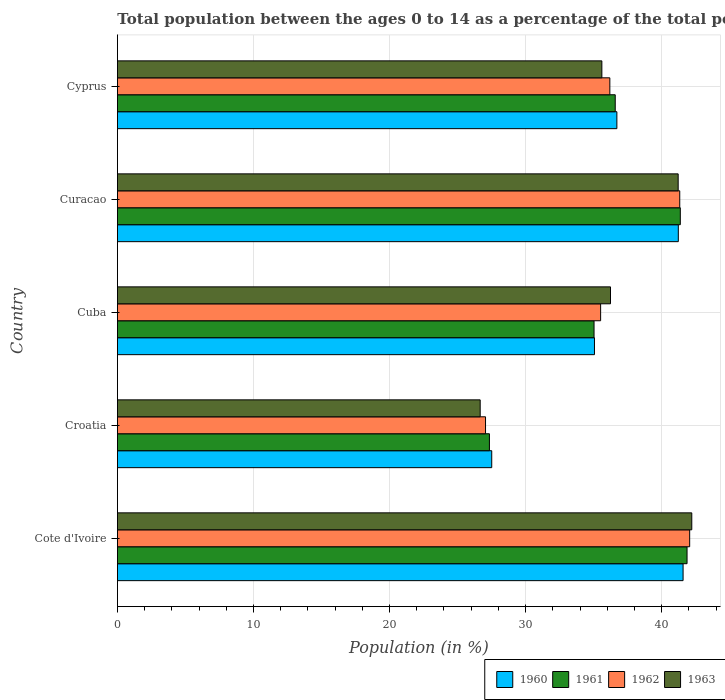What is the label of the 4th group of bars from the top?
Your response must be concise. Croatia. What is the percentage of the population ages 0 to 14 in 1961 in Curacao?
Your answer should be very brief. 41.37. Across all countries, what is the maximum percentage of the population ages 0 to 14 in 1963?
Ensure brevity in your answer.  42.21. Across all countries, what is the minimum percentage of the population ages 0 to 14 in 1962?
Your answer should be compact. 27.05. In which country was the percentage of the population ages 0 to 14 in 1960 maximum?
Offer a very short reply. Cote d'Ivoire. In which country was the percentage of the population ages 0 to 14 in 1963 minimum?
Your answer should be very brief. Croatia. What is the total percentage of the population ages 0 to 14 in 1963 in the graph?
Provide a succinct answer. 181.93. What is the difference between the percentage of the population ages 0 to 14 in 1963 in Curacao and that in Cyprus?
Keep it short and to the point. 5.61. What is the difference between the percentage of the population ages 0 to 14 in 1962 in Croatia and the percentage of the population ages 0 to 14 in 1961 in Cote d'Ivoire?
Your answer should be very brief. -14.81. What is the average percentage of the population ages 0 to 14 in 1961 per country?
Your answer should be very brief. 36.44. What is the difference between the percentage of the population ages 0 to 14 in 1963 and percentage of the population ages 0 to 14 in 1962 in Cyprus?
Give a very brief answer. -0.59. In how many countries, is the percentage of the population ages 0 to 14 in 1963 greater than 18 ?
Make the answer very short. 5. What is the ratio of the percentage of the population ages 0 to 14 in 1962 in Cuba to that in Cyprus?
Give a very brief answer. 0.98. Is the percentage of the population ages 0 to 14 in 1961 in Croatia less than that in Curacao?
Keep it short and to the point. Yes. Is the difference between the percentage of the population ages 0 to 14 in 1963 in Cuba and Curacao greater than the difference between the percentage of the population ages 0 to 14 in 1962 in Cuba and Curacao?
Offer a terse response. Yes. What is the difference between the highest and the second highest percentage of the population ages 0 to 14 in 1963?
Your answer should be compact. 1. What is the difference between the highest and the lowest percentage of the population ages 0 to 14 in 1963?
Keep it short and to the point. 15.55. Is the sum of the percentage of the population ages 0 to 14 in 1963 in Curacao and Cyprus greater than the maximum percentage of the population ages 0 to 14 in 1961 across all countries?
Give a very brief answer. Yes. Is it the case that in every country, the sum of the percentage of the population ages 0 to 14 in 1963 and percentage of the population ages 0 to 14 in 1961 is greater than the sum of percentage of the population ages 0 to 14 in 1962 and percentage of the population ages 0 to 14 in 1960?
Make the answer very short. No. What does the 3rd bar from the top in Curacao represents?
Ensure brevity in your answer.  1961. What does the 2nd bar from the bottom in Croatia represents?
Offer a very short reply. 1961. Is it the case that in every country, the sum of the percentage of the population ages 0 to 14 in 1960 and percentage of the population ages 0 to 14 in 1963 is greater than the percentage of the population ages 0 to 14 in 1961?
Provide a succinct answer. Yes. How many countries are there in the graph?
Give a very brief answer. 5. What is the difference between two consecutive major ticks on the X-axis?
Make the answer very short. 10. Does the graph contain grids?
Your answer should be very brief. Yes. How many legend labels are there?
Give a very brief answer. 4. What is the title of the graph?
Your answer should be compact. Total population between the ages 0 to 14 as a percentage of the total population. Does "2011" appear as one of the legend labels in the graph?
Your answer should be very brief. No. What is the label or title of the X-axis?
Make the answer very short. Population (in %). What is the Population (in %) in 1960 in Cote d'Ivoire?
Your answer should be very brief. 41.57. What is the Population (in %) of 1961 in Cote d'Ivoire?
Give a very brief answer. 41.86. What is the Population (in %) of 1962 in Cote d'Ivoire?
Ensure brevity in your answer.  42.06. What is the Population (in %) in 1963 in Cote d'Ivoire?
Provide a short and direct response. 42.21. What is the Population (in %) of 1960 in Croatia?
Your answer should be very brief. 27.51. What is the Population (in %) of 1961 in Croatia?
Give a very brief answer. 27.34. What is the Population (in %) in 1962 in Croatia?
Your answer should be very brief. 27.05. What is the Population (in %) in 1963 in Croatia?
Keep it short and to the point. 26.66. What is the Population (in %) in 1960 in Cuba?
Keep it short and to the point. 35.06. What is the Population (in %) in 1961 in Cuba?
Your answer should be compact. 35.03. What is the Population (in %) of 1962 in Cuba?
Your response must be concise. 35.51. What is the Population (in %) of 1963 in Cuba?
Offer a very short reply. 36.24. What is the Population (in %) in 1960 in Curacao?
Make the answer very short. 41.22. What is the Population (in %) in 1961 in Curacao?
Your answer should be very brief. 41.37. What is the Population (in %) of 1962 in Curacao?
Ensure brevity in your answer.  41.33. What is the Population (in %) of 1963 in Curacao?
Offer a very short reply. 41.21. What is the Population (in %) in 1960 in Cyprus?
Keep it short and to the point. 36.71. What is the Population (in %) of 1961 in Cyprus?
Ensure brevity in your answer.  36.59. What is the Population (in %) of 1962 in Cyprus?
Provide a succinct answer. 36.19. What is the Population (in %) of 1963 in Cyprus?
Your response must be concise. 35.6. Across all countries, what is the maximum Population (in %) in 1960?
Offer a very short reply. 41.57. Across all countries, what is the maximum Population (in %) in 1961?
Offer a very short reply. 41.86. Across all countries, what is the maximum Population (in %) in 1962?
Your response must be concise. 42.06. Across all countries, what is the maximum Population (in %) in 1963?
Your answer should be very brief. 42.21. Across all countries, what is the minimum Population (in %) of 1960?
Provide a short and direct response. 27.51. Across all countries, what is the minimum Population (in %) of 1961?
Ensure brevity in your answer.  27.34. Across all countries, what is the minimum Population (in %) of 1962?
Offer a terse response. 27.05. Across all countries, what is the minimum Population (in %) in 1963?
Provide a short and direct response. 26.66. What is the total Population (in %) in 1960 in the graph?
Provide a succinct answer. 182.07. What is the total Population (in %) in 1961 in the graph?
Provide a short and direct response. 182.19. What is the total Population (in %) of 1962 in the graph?
Keep it short and to the point. 182.14. What is the total Population (in %) of 1963 in the graph?
Offer a terse response. 181.93. What is the difference between the Population (in %) in 1960 in Cote d'Ivoire and that in Croatia?
Your answer should be compact. 14.06. What is the difference between the Population (in %) in 1961 in Cote d'Ivoire and that in Croatia?
Ensure brevity in your answer.  14.52. What is the difference between the Population (in %) of 1962 in Cote d'Ivoire and that in Croatia?
Your response must be concise. 15. What is the difference between the Population (in %) in 1963 in Cote d'Ivoire and that in Croatia?
Offer a terse response. 15.55. What is the difference between the Population (in %) in 1960 in Cote d'Ivoire and that in Cuba?
Keep it short and to the point. 6.51. What is the difference between the Population (in %) of 1961 in Cote d'Ivoire and that in Cuba?
Give a very brief answer. 6.84. What is the difference between the Population (in %) of 1962 in Cote d'Ivoire and that in Cuba?
Provide a short and direct response. 6.54. What is the difference between the Population (in %) in 1963 in Cote d'Ivoire and that in Cuba?
Your response must be concise. 5.97. What is the difference between the Population (in %) in 1960 in Cote d'Ivoire and that in Curacao?
Keep it short and to the point. 0.35. What is the difference between the Population (in %) of 1961 in Cote d'Ivoire and that in Curacao?
Your answer should be compact. 0.49. What is the difference between the Population (in %) of 1962 in Cote d'Ivoire and that in Curacao?
Your response must be concise. 0.73. What is the difference between the Population (in %) in 1963 in Cote d'Ivoire and that in Curacao?
Ensure brevity in your answer.  1. What is the difference between the Population (in %) of 1960 in Cote d'Ivoire and that in Cyprus?
Keep it short and to the point. 4.87. What is the difference between the Population (in %) of 1961 in Cote d'Ivoire and that in Cyprus?
Your answer should be compact. 5.28. What is the difference between the Population (in %) in 1962 in Cote d'Ivoire and that in Cyprus?
Give a very brief answer. 5.87. What is the difference between the Population (in %) in 1963 in Cote d'Ivoire and that in Cyprus?
Give a very brief answer. 6.61. What is the difference between the Population (in %) of 1960 in Croatia and that in Cuba?
Your response must be concise. -7.55. What is the difference between the Population (in %) in 1961 in Croatia and that in Cuba?
Your answer should be very brief. -7.69. What is the difference between the Population (in %) of 1962 in Croatia and that in Cuba?
Ensure brevity in your answer.  -8.46. What is the difference between the Population (in %) in 1963 in Croatia and that in Cuba?
Provide a succinct answer. -9.58. What is the difference between the Population (in %) in 1960 in Croatia and that in Curacao?
Give a very brief answer. -13.71. What is the difference between the Population (in %) of 1961 in Croatia and that in Curacao?
Give a very brief answer. -14.03. What is the difference between the Population (in %) of 1962 in Croatia and that in Curacao?
Offer a very short reply. -14.27. What is the difference between the Population (in %) in 1963 in Croatia and that in Curacao?
Keep it short and to the point. -14.55. What is the difference between the Population (in %) of 1960 in Croatia and that in Cyprus?
Make the answer very short. -9.2. What is the difference between the Population (in %) of 1961 in Croatia and that in Cyprus?
Make the answer very short. -9.25. What is the difference between the Population (in %) of 1962 in Croatia and that in Cyprus?
Your answer should be very brief. -9.14. What is the difference between the Population (in %) of 1963 in Croatia and that in Cyprus?
Keep it short and to the point. -8.94. What is the difference between the Population (in %) of 1960 in Cuba and that in Curacao?
Your response must be concise. -6.16. What is the difference between the Population (in %) of 1961 in Cuba and that in Curacao?
Keep it short and to the point. -6.34. What is the difference between the Population (in %) in 1962 in Cuba and that in Curacao?
Offer a very short reply. -5.82. What is the difference between the Population (in %) in 1963 in Cuba and that in Curacao?
Your answer should be compact. -4.97. What is the difference between the Population (in %) in 1960 in Cuba and that in Cyprus?
Give a very brief answer. -1.65. What is the difference between the Population (in %) in 1961 in Cuba and that in Cyprus?
Provide a succinct answer. -1.56. What is the difference between the Population (in %) in 1962 in Cuba and that in Cyprus?
Ensure brevity in your answer.  -0.68. What is the difference between the Population (in %) in 1963 in Cuba and that in Cyprus?
Give a very brief answer. 0.63. What is the difference between the Population (in %) of 1960 in Curacao and that in Cyprus?
Your answer should be compact. 4.52. What is the difference between the Population (in %) of 1961 in Curacao and that in Cyprus?
Give a very brief answer. 4.78. What is the difference between the Population (in %) of 1962 in Curacao and that in Cyprus?
Give a very brief answer. 5.14. What is the difference between the Population (in %) of 1963 in Curacao and that in Cyprus?
Offer a very short reply. 5.61. What is the difference between the Population (in %) in 1960 in Cote d'Ivoire and the Population (in %) in 1961 in Croatia?
Make the answer very short. 14.23. What is the difference between the Population (in %) in 1960 in Cote d'Ivoire and the Population (in %) in 1962 in Croatia?
Your response must be concise. 14.52. What is the difference between the Population (in %) in 1960 in Cote d'Ivoire and the Population (in %) in 1963 in Croatia?
Your answer should be compact. 14.91. What is the difference between the Population (in %) of 1961 in Cote d'Ivoire and the Population (in %) of 1962 in Croatia?
Your answer should be very brief. 14.81. What is the difference between the Population (in %) of 1961 in Cote d'Ivoire and the Population (in %) of 1963 in Croatia?
Give a very brief answer. 15.2. What is the difference between the Population (in %) of 1962 in Cote d'Ivoire and the Population (in %) of 1963 in Croatia?
Make the answer very short. 15.4. What is the difference between the Population (in %) of 1960 in Cote d'Ivoire and the Population (in %) of 1961 in Cuba?
Ensure brevity in your answer.  6.54. What is the difference between the Population (in %) in 1960 in Cote d'Ivoire and the Population (in %) in 1962 in Cuba?
Offer a terse response. 6.06. What is the difference between the Population (in %) of 1960 in Cote d'Ivoire and the Population (in %) of 1963 in Cuba?
Your answer should be compact. 5.33. What is the difference between the Population (in %) in 1961 in Cote d'Ivoire and the Population (in %) in 1962 in Cuba?
Provide a short and direct response. 6.35. What is the difference between the Population (in %) in 1961 in Cote d'Ivoire and the Population (in %) in 1963 in Cuba?
Ensure brevity in your answer.  5.63. What is the difference between the Population (in %) of 1962 in Cote d'Ivoire and the Population (in %) of 1963 in Cuba?
Offer a terse response. 5.82. What is the difference between the Population (in %) of 1960 in Cote d'Ivoire and the Population (in %) of 1961 in Curacao?
Offer a very short reply. 0.2. What is the difference between the Population (in %) in 1960 in Cote d'Ivoire and the Population (in %) in 1962 in Curacao?
Keep it short and to the point. 0.24. What is the difference between the Population (in %) in 1960 in Cote d'Ivoire and the Population (in %) in 1963 in Curacao?
Your answer should be compact. 0.36. What is the difference between the Population (in %) in 1961 in Cote d'Ivoire and the Population (in %) in 1962 in Curacao?
Your response must be concise. 0.54. What is the difference between the Population (in %) in 1961 in Cote d'Ivoire and the Population (in %) in 1963 in Curacao?
Your answer should be very brief. 0.65. What is the difference between the Population (in %) in 1962 in Cote d'Ivoire and the Population (in %) in 1963 in Curacao?
Make the answer very short. 0.84. What is the difference between the Population (in %) of 1960 in Cote d'Ivoire and the Population (in %) of 1961 in Cyprus?
Provide a short and direct response. 4.99. What is the difference between the Population (in %) in 1960 in Cote d'Ivoire and the Population (in %) in 1962 in Cyprus?
Offer a terse response. 5.38. What is the difference between the Population (in %) of 1960 in Cote d'Ivoire and the Population (in %) of 1963 in Cyprus?
Keep it short and to the point. 5.97. What is the difference between the Population (in %) of 1961 in Cote d'Ivoire and the Population (in %) of 1962 in Cyprus?
Your answer should be very brief. 5.67. What is the difference between the Population (in %) in 1961 in Cote d'Ivoire and the Population (in %) in 1963 in Cyprus?
Offer a terse response. 6.26. What is the difference between the Population (in %) of 1962 in Cote d'Ivoire and the Population (in %) of 1963 in Cyprus?
Provide a short and direct response. 6.45. What is the difference between the Population (in %) of 1960 in Croatia and the Population (in %) of 1961 in Cuba?
Your response must be concise. -7.52. What is the difference between the Population (in %) in 1960 in Croatia and the Population (in %) in 1962 in Cuba?
Your answer should be compact. -8. What is the difference between the Population (in %) of 1960 in Croatia and the Population (in %) of 1963 in Cuba?
Offer a terse response. -8.73. What is the difference between the Population (in %) of 1961 in Croatia and the Population (in %) of 1962 in Cuba?
Provide a succinct answer. -8.17. What is the difference between the Population (in %) in 1961 in Croatia and the Population (in %) in 1963 in Cuba?
Keep it short and to the point. -8.9. What is the difference between the Population (in %) of 1962 in Croatia and the Population (in %) of 1963 in Cuba?
Your answer should be compact. -9.18. What is the difference between the Population (in %) in 1960 in Croatia and the Population (in %) in 1961 in Curacao?
Ensure brevity in your answer.  -13.86. What is the difference between the Population (in %) in 1960 in Croatia and the Population (in %) in 1962 in Curacao?
Give a very brief answer. -13.82. What is the difference between the Population (in %) in 1960 in Croatia and the Population (in %) in 1963 in Curacao?
Keep it short and to the point. -13.7. What is the difference between the Population (in %) in 1961 in Croatia and the Population (in %) in 1962 in Curacao?
Ensure brevity in your answer.  -13.99. What is the difference between the Population (in %) in 1961 in Croatia and the Population (in %) in 1963 in Curacao?
Your answer should be compact. -13.87. What is the difference between the Population (in %) in 1962 in Croatia and the Population (in %) in 1963 in Curacao?
Your answer should be very brief. -14.16. What is the difference between the Population (in %) in 1960 in Croatia and the Population (in %) in 1961 in Cyprus?
Keep it short and to the point. -9.08. What is the difference between the Population (in %) in 1960 in Croatia and the Population (in %) in 1962 in Cyprus?
Provide a short and direct response. -8.68. What is the difference between the Population (in %) of 1960 in Croatia and the Population (in %) of 1963 in Cyprus?
Offer a very short reply. -8.09. What is the difference between the Population (in %) of 1961 in Croatia and the Population (in %) of 1962 in Cyprus?
Your answer should be very brief. -8.85. What is the difference between the Population (in %) in 1961 in Croatia and the Population (in %) in 1963 in Cyprus?
Give a very brief answer. -8.26. What is the difference between the Population (in %) in 1962 in Croatia and the Population (in %) in 1963 in Cyprus?
Your answer should be very brief. -8.55. What is the difference between the Population (in %) in 1960 in Cuba and the Population (in %) in 1961 in Curacao?
Your answer should be compact. -6.31. What is the difference between the Population (in %) in 1960 in Cuba and the Population (in %) in 1962 in Curacao?
Your answer should be very brief. -6.27. What is the difference between the Population (in %) of 1960 in Cuba and the Population (in %) of 1963 in Curacao?
Give a very brief answer. -6.15. What is the difference between the Population (in %) of 1961 in Cuba and the Population (in %) of 1962 in Curacao?
Give a very brief answer. -6.3. What is the difference between the Population (in %) of 1961 in Cuba and the Population (in %) of 1963 in Curacao?
Provide a short and direct response. -6.18. What is the difference between the Population (in %) of 1962 in Cuba and the Population (in %) of 1963 in Curacao?
Give a very brief answer. -5.7. What is the difference between the Population (in %) in 1960 in Cuba and the Population (in %) in 1961 in Cyprus?
Provide a short and direct response. -1.53. What is the difference between the Population (in %) of 1960 in Cuba and the Population (in %) of 1962 in Cyprus?
Offer a terse response. -1.13. What is the difference between the Population (in %) in 1960 in Cuba and the Population (in %) in 1963 in Cyprus?
Keep it short and to the point. -0.54. What is the difference between the Population (in %) in 1961 in Cuba and the Population (in %) in 1962 in Cyprus?
Provide a succinct answer. -1.16. What is the difference between the Population (in %) of 1961 in Cuba and the Population (in %) of 1963 in Cyprus?
Offer a very short reply. -0.58. What is the difference between the Population (in %) of 1962 in Cuba and the Population (in %) of 1963 in Cyprus?
Keep it short and to the point. -0.09. What is the difference between the Population (in %) in 1960 in Curacao and the Population (in %) in 1961 in Cyprus?
Keep it short and to the point. 4.64. What is the difference between the Population (in %) of 1960 in Curacao and the Population (in %) of 1962 in Cyprus?
Your answer should be compact. 5.03. What is the difference between the Population (in %) in 1960 in Curacao and the Population (in %) in 1963 in Cyprus?
Offer a very short reply. 5.62. What is the difference between the Population (in %) in 1961 in Curacao and the Population (in %) in 1962 in Cyprus?
Keep it short and to the point. 5.18. What is the difference between the Population (in %) of 1961 in Curacao and the Population (in %) of 1963 in Cyprus?
Your response must be concise. 5.77. What is the difference between the Population (in %) in 1962 in Curacao and the Population (in %) in 1963 in Cyprus?
Your answer should be compact. 5.72. What is the average Population (in %) in 1960 per country?
Your response must be concise. 36.41. What is the average Population (in %) of 1961 per country?
Provide a succinct answer. 36.44. What is the average Population (in %) in 1962 per country?
Give a very brief answer. 36.43. What is the average Population (in %) in 1963 per country?
Keep it short and to the point. 36.39. What is the difference between the Population (in %) in 1960 and Population (in %) in 1961 in Cote d'Ivoire?
Your answer should be compact. -0.29. What is the difference between the Population (in %) in 1960 and Population (in %) in 1962 in Cote d'Ivoire?
Keep it short and to the point. -0.48. What is the difference between the Population (in %) of 1960 and Population (in %) of 1963 in Cote d'Ivoire?
Your answer should be compact. -0.64. What is the difference between the Population (in %) of 1961 and Population (in %) of 1962 in Cote d'Ivoire?
Give a very brief answer. -0.19. What is the difference between the Population (in %) in 1961 and Population (in %) in 1963 in Cote d'Ivoire?
Your response must be concise. -0.35. What is the difference between the Population (in %) in 1962 and Population (in %) in 1963 in Cote d'Ivoire?
Keep it short and to the point. -0.15. What is the difference between the Population (in %) in 1960 and Population (in %) in 1961 in Croatia?
Keep it short and to the point. 0.17. What is the difference between the Population (in %) of 1960 and Population (in %) of 1962 in Croatia?
Your answer should be very brief. 0.46. What is the difference between the Population (in %) in 1960 and Population (in %) in 1963 in Croatia?
Ensure brevity in your answer.  0.85. What is the difference between the Population (in %) of 1961 and Population (in %) of 1962 in Croatia?
Your answer should be compact. 0.29. What is the difference between the Population (in %) in 1961 and Population (in %) in 1963 in Croatia?
Your response must be concise. 0.68. What is the difference between the Population (in %) of 1962 and Population (in %) of 1963 in Croatia?
Offer a very short reply. 0.39. What is the difference between the Population (in %) in 1960 and Population (in %) in 1961 in Cuba?
Keep it short and to the point. 0.03. What is the difference between the Population (in %) in 1960 and Population (in %) in 1962 in Cuba?
Your answer should be very brief. -0.45. What is the difference between the Population (in %) in 1960 and Population (in %) in 1963 in Cuba?
Offer a very short reply. -1.18. What is the difference between the Population (in %) in 1961 and Population (in %) in 1962 in Cuba?
Ensure brevity in your answer.  -0.48. What is the difference between the Population (in %) of 1961 and Population (in %) of 1963 in Cuba?
Provide a succinct answer. -1.21. What is the difference between the Population (in %) in 1962 and Population (in %) in 1963 in Cuba?
Keep it short and to the point. -0.73. What is the difference between the Population (in %) in 1960 and Population (in %) in 1961 in Curacao?
Provide a succinct answer. -0.15. What is the difference between the Population (in %) in 1960 and Population (in %) in 1962 in Curacao?
Give a very brief answer. -0.11. What is the difference between the Population (in %) in 1960 and Population (in %) in 1963 in Curacao?
Your answer should be compact. 0.01. What is the difference between the Population (in %) in 1961 and Population (in %) in 1962 in Curacao?
Your answer should be very brief. 0.04. What is the difference between the Population (in %) of 1961 and Population (in %) of 1963 in Curacao?
Ensure brevity in your answer.  0.16. What is the difference between the Population (in %) in 1962 and Population (in %) in 1963 in Curacao?
Ensure brevity in your answer.  0.12. What is the difference between the Population (in %) in 1960 and Population (in %) in 1961 in Cyprus?
Offer a terse response. 0.12. What is the difference between the Population (in %) in 1960 and Population (in %) in 1962 in Cyprus?
Your answer should be very brief. 0.52. What is the difference between the Population (in %) of 1960 and Population (in %) of 1963 in Cyprus?
Make the answer very short. 1.1. What is the difference between the Population (in %) in 1961 and Population (in %) in 1962 in Cyprus?
Offer a very short reply. 0.4. What is the difference between the Population (in %) of 1961 and Population (in %) of 1963 in Cyprus?
Offer a very short reply. 0.98. What is the difference between the Population (in %) of 1962 and Population (in %) of 1963 in Cyprus?
Give a very brief answer. 0.59. What is the ratio of the Population (in %) in 1960 in Cote d'Ivoire to that in Croatia?
Your response must be concise. 1.51. What is the ratio of the Population (in %) in 1961 in Cote d'Ivoire to that in Croatia?
Your answer should be very brief. 1.53. What is the ratio of the Population (in %) in 1962 in Cote d'Ivoire to that in Croatia?
Your answer should be very brief. 1.55. What is the ratio of the Population (in %) in 1963 in Cote d'Ivoire to that in Croatia?
Your answer should be very brief. 1.58. What is the ratio of the Population (in %) of 1960 in Cote d'Ivoire to that in Cuba?
Give a very brief answer. 1.19. What is the ratio of the Population (in %) of 1961 in Cote d'Ivoire to that in Cuba?
Give a very brief answer. 1.2. What is the ratio of the Population (in %) in 1962 in Cote d'Ivoire to that in Cuba?
Provide a succinct answer. 1.18. What is the ratio of the Population (in %) of 1963 in Cote d'Ivoire to that in Cuba?
Your response must be concise. 1.16. What is the ratio of the Population (in %) of 1960 in Cote d'Ivoire to that in Curacao?
Your answer should be compact. 1.01. What is the ratio of the Population (in %) in 1961 in Cote d'Ivoire to that in Curacao?
Make the answer very short. 1.01. What is the ratio of the Population (in %) of 1962 in Cote d'Ivoire to that in Curacao?
Offer a very short reply. 1.02. What is the ratio of the Population (in %) in 1963 in Cote d'Ivoire to that in Curacao?
Give a very brief answer. 1.02. What is the ratio of the Population (in %) of 1960 in Cote d'Ivoire to that in Cyprus?
Offer a terse response. 1.13. What is the ratio of the Population (in %) in 1961 in Cote d'Ivoire to that in Cyprus?
Keep it short and to the point. 1.14. What is the ratio of the Population (in %) of 1962 in Cote d'Ivoire to that in Cyprus?
Keep it short and to the point. 1.16. What is the ratio of the Population (in %) in 1963 in Cote d'Ivoire to that in Cyprus?
Give a very brief answer. 1.19. What is the ratio of the Population (in %) in 1960 in Croatia to that in Cuba?
Provide a short and direct response. 0.78. What is the ratio of the Population (in %) of 1961 in Croatia to that in Cuba?
Provide a short and direct response. 0.78. What is the ratio of the Population (in %) of 1962 in Croatia to that in Cuba?
Your response must be concise. 0.76. What is the ratio of the Population (in %) of 1963 in Croatia to that in Cuba?
Keep it short and to the point. 0.74. What is the ratio of the Population (in %) in 1960 in Croatia to that in Curacao?
Ensure brevity in your answer.  0.67. What is the ratio of the Population (in %) of 1961 in Croatia to that in Curacao?
Give a very brief answer. 0.66. What is the ratio of the Population (in %) of 1962 in Croatia to that in Curacao?
Offer a terse response. 0.65. What is the ratio of the Population (in %) in 1963 in Croatia to that in Curacao?
Your response must be concise. 0.65. What is the ratio of the Population (in %) of 1960 in Croatia to that in Cyprus?
Provide a short and direct response. 0.75. What is the ratio of the Population (in %) in 1961 in Croatia to that in Cyprus?
Offer a terse response. 0.75. What is the ratio of the Population (in %) of 1962 in Croatia to that in Cyprus?
Ensure brevity in your answer.  0.75. What is the ratio of the Population (in %) in 1963 in Croatia to that in Cyprus?
Keep it short and to the point. 0.75. What is the ratio of the Population (in %) in 1960 in Cuba to that in Curacao?
Give a very brief answer. 0.85. What is the ratio of the Population (in %) of 1961 in Cuba to that in Curacao?
Provide a short and direct response. 0.85. What is the ratio of the Population (in %) in 1962 in Cuba to that in Curacao?
Offer a terse response. 0.86. What is the ratio of the Population (in %) of 1963 in Cuba to that in Curacao?
Offer a very short reply. 0.88. What is the ratio of the Population (in %) in 1960 in Cuba to that in Cyprus?
Keep it short and to the point. 0.96. What is the ratio of the Population (in %) of 1961 in Cuba to that in Cyprus?
Ensure brevity in your answer.  0.96. What is the ratio of the Population (in %) of 1962 in Cuba to that in Cyprus?
Your answer should be very brief. 0.98. What is the ratio of the Population (in %) of 1963 in Cuba to that in Cyprus?
Your answer should be very brief. 1.02. What is the ratio of the Population (in %) of 1960 in Curacao to that in Cyprus?
Offer a terse response. 1.12. What is the ratio of the Population (in %) in 1961 in Curacao to that in Cyprus?
Your answer should be compact. 1.13. What is the ratio of the Population (in %) of 1962 in Curacao to that in Cyprus?
Offer a very short reply. 1.14. What is the ratio of the Population (in %) in 1963 in Curacao to that in Cyprus?
Provide a succinct answer. 1.16. What is the difference between the highest and the second highest Population (in %) of 1960?
Give a very brief answer. 0.35. What is the difference between the highest and the second highest Population (in %) of 1961?
Your answer should be compact. 0.49. What is the difference between the highest and the second highest Population (in %) in 1962?
Make the answer very short. 0.73. What is the difference between the highest and the lowest Population (in %) in 1960?
Your answer should be compact. 14.06. What is the difference between the highest and the lowest Population (in %) in 1961?
Keep it short and to the point. 14.52. What is the difference between the highest and the lowest Population (in %) of 1962?
Ensure brevity in your answer.  15. What is the difference between the highest and the lowest Population (in %) in 1963?
Give a very brief answer. 15.55. 